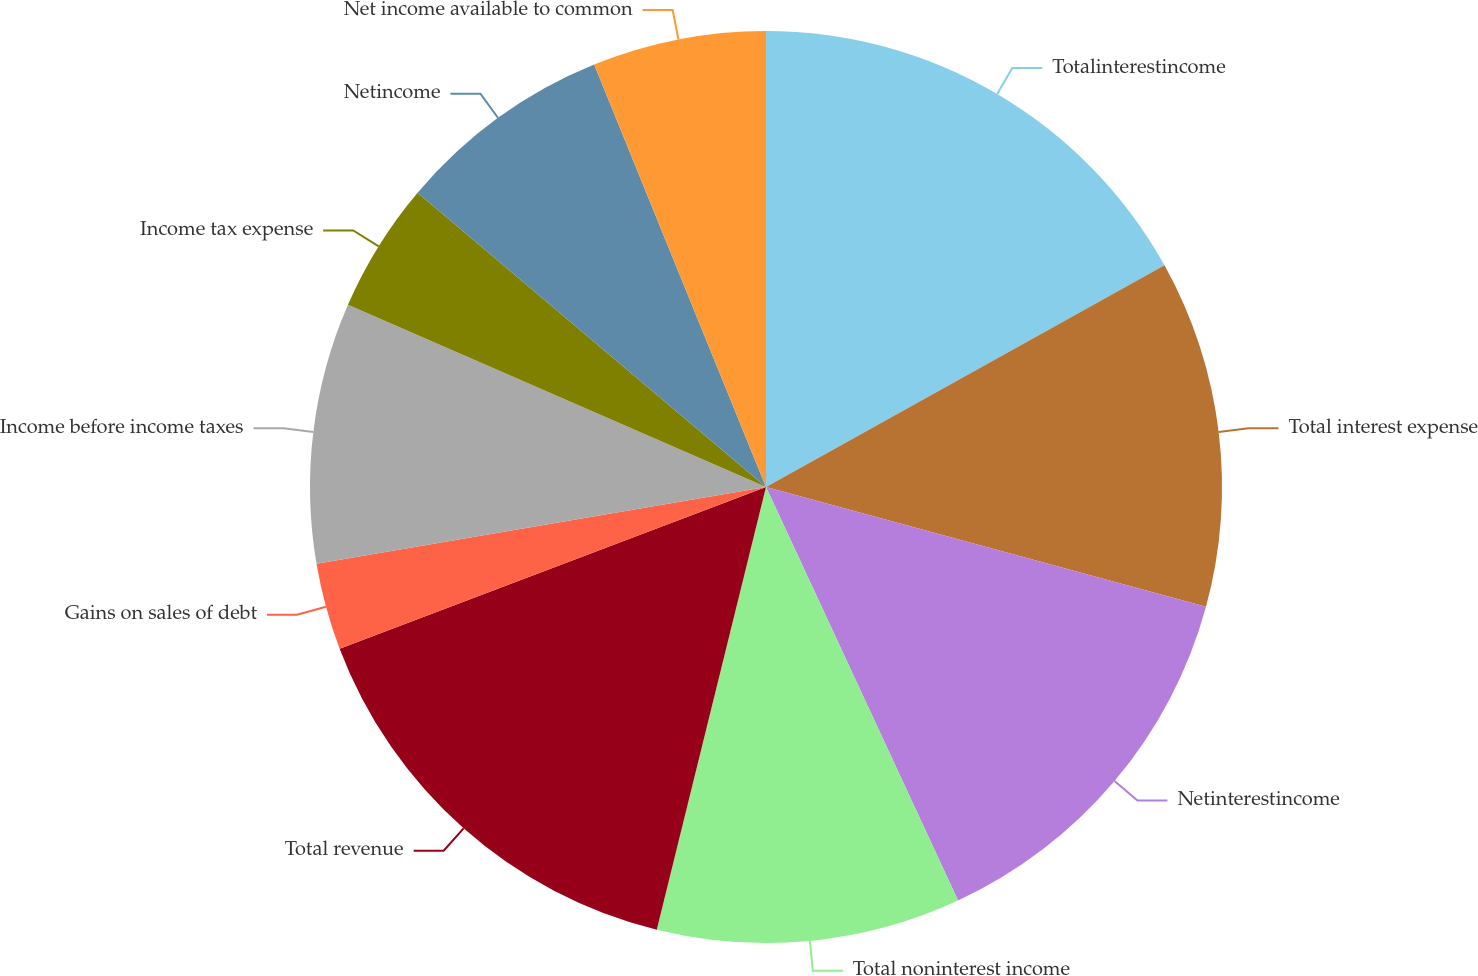<chart> <loc_0><loc_0><loc_500><loc_500><pie_chart><fcel>Totalinterestincome<fcel>Total interest expense<fcel>Netinterestincome<fcel>Total noninterest income<fcel>Total revenue<fcel>Gains on sales of debt<fcel>Income before income taxes<fcel>Income tax expense<fcel>Netincome<fcel>Net income available to common<nl><fcel>16.92%<fcel>12.31%<fcel>13.85%<fcel>10.77%<fcel>15.38%<fcel>3.08%<fcel>9.23%<fcel>4.62%<fcel>7.69%<fcel>6.15%<nl></chart> 